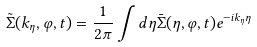Convert formula to latex. <formula><loc_0><loc_0><loc_500><loc_500>\tilde { \Sigma } ( k _ { \eta } , \varphi , t ) = \frac { 1 } { 2 \pi } \int d \eta \bar { \Sigma } ( \eta , \varphi , t ) e ^ { - i k _ { \eta } \eta }</formula> 